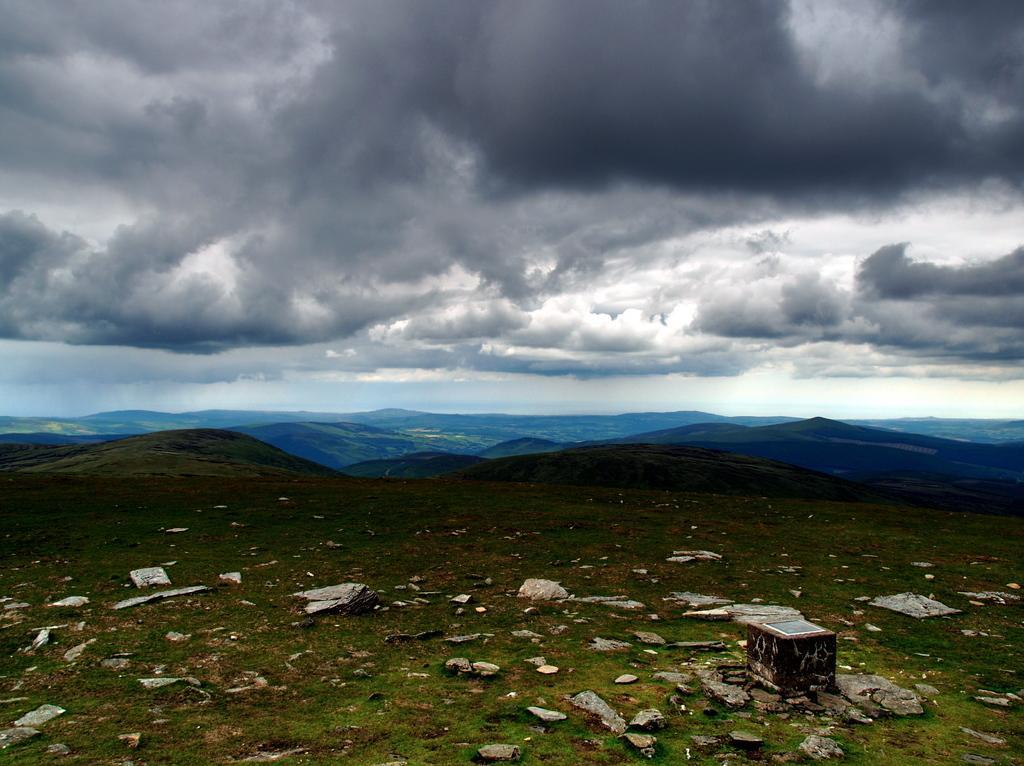In one or two sentences, can you explain what this image depicts? In this picture we can see a few stones on the grass. We can see an object on the right side. It looks like a few mountains are visible in the background. Sky is cloudy. 